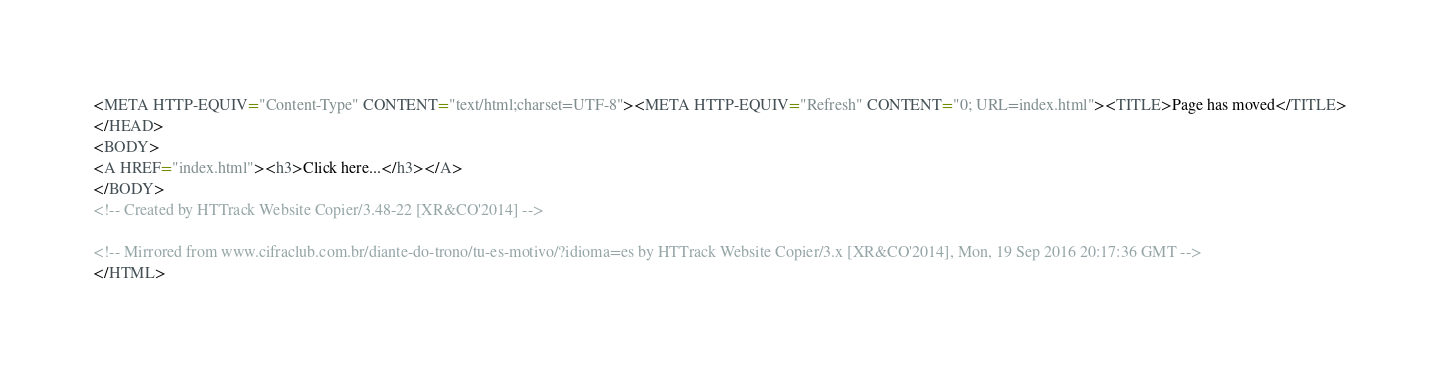<code> <loc_0><loc_0><loc_500><loc_500><_HTML_><META HTTP-EQUIV="Content-Type" CONTENT="text/html;charset=UTF-8"><META HTTP-EQUIV="Refresh" CONTENT="0; URL=index.html"><TITLE>Page has moved</TITLE>
</HEAD>
<BODY>
<A HREF="index.html"><h3>Click here...</h3></A>
</BODY>
<!-- Created by HTTrack Website Copier/3.48-22 [XR&CO'2014] -->

<!-- Mirrored from www.cifraclub.com.br/diante-do-trono/tu-es-motivo/?idioma=es by HTTrack Website Copier/3.x [XR&CO'2014], Mon, 19 Sep 2016 20:17:36 GMT -->
</HTML>
</code> 